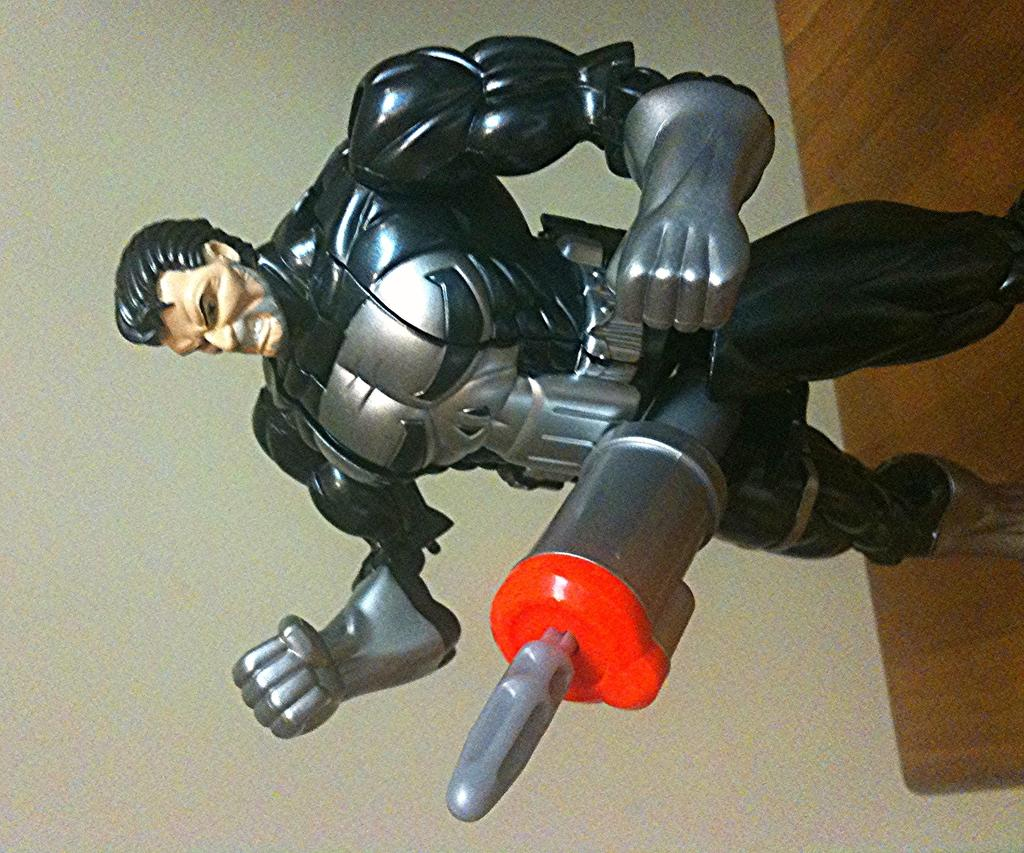What is the color of the toy in the image? The toy in the image is black and silver colored. Where is the toy located in the image? The toy is present on a table. What type of quilt is draped over the toy in the image? There is no quilt present in the image; it only features a black and silver colored toy on a table. 